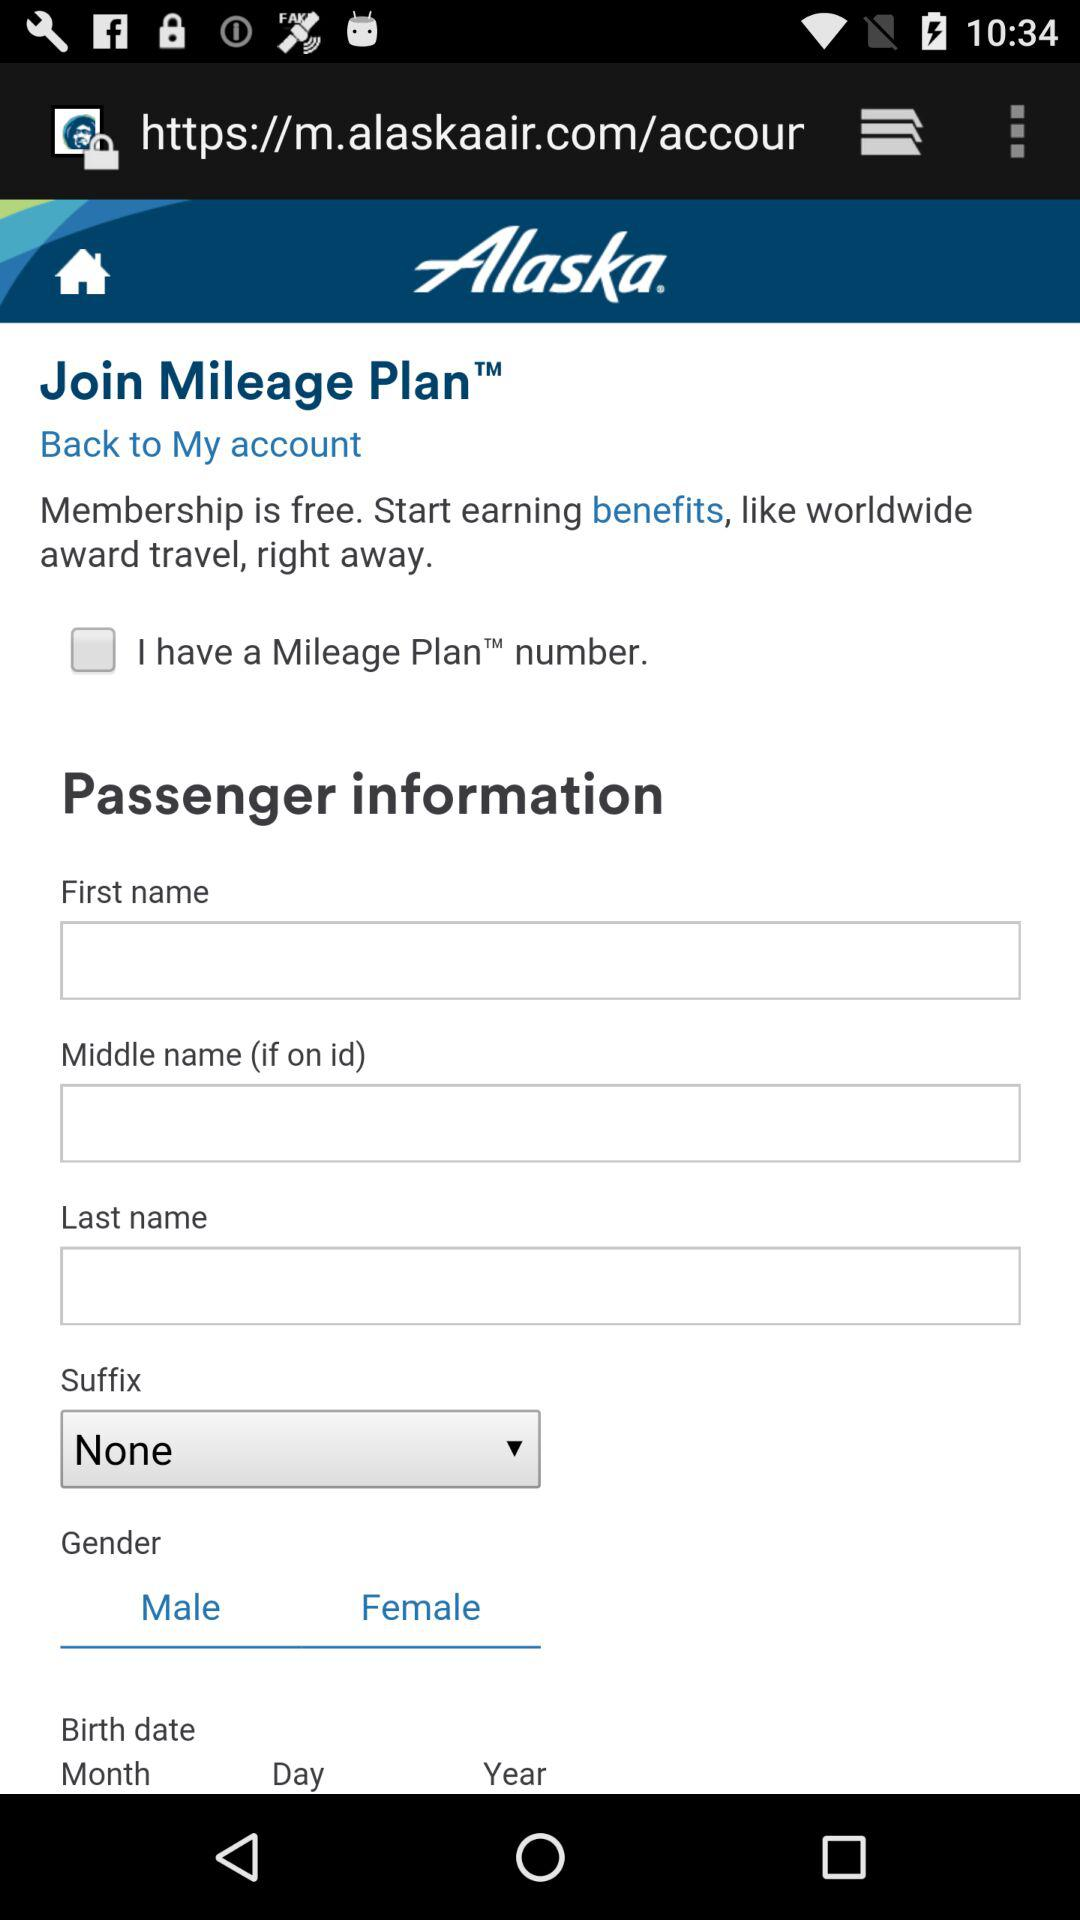How many text fields are there for the passenger's last name?
Answer the question using a single word or phrase. 2 